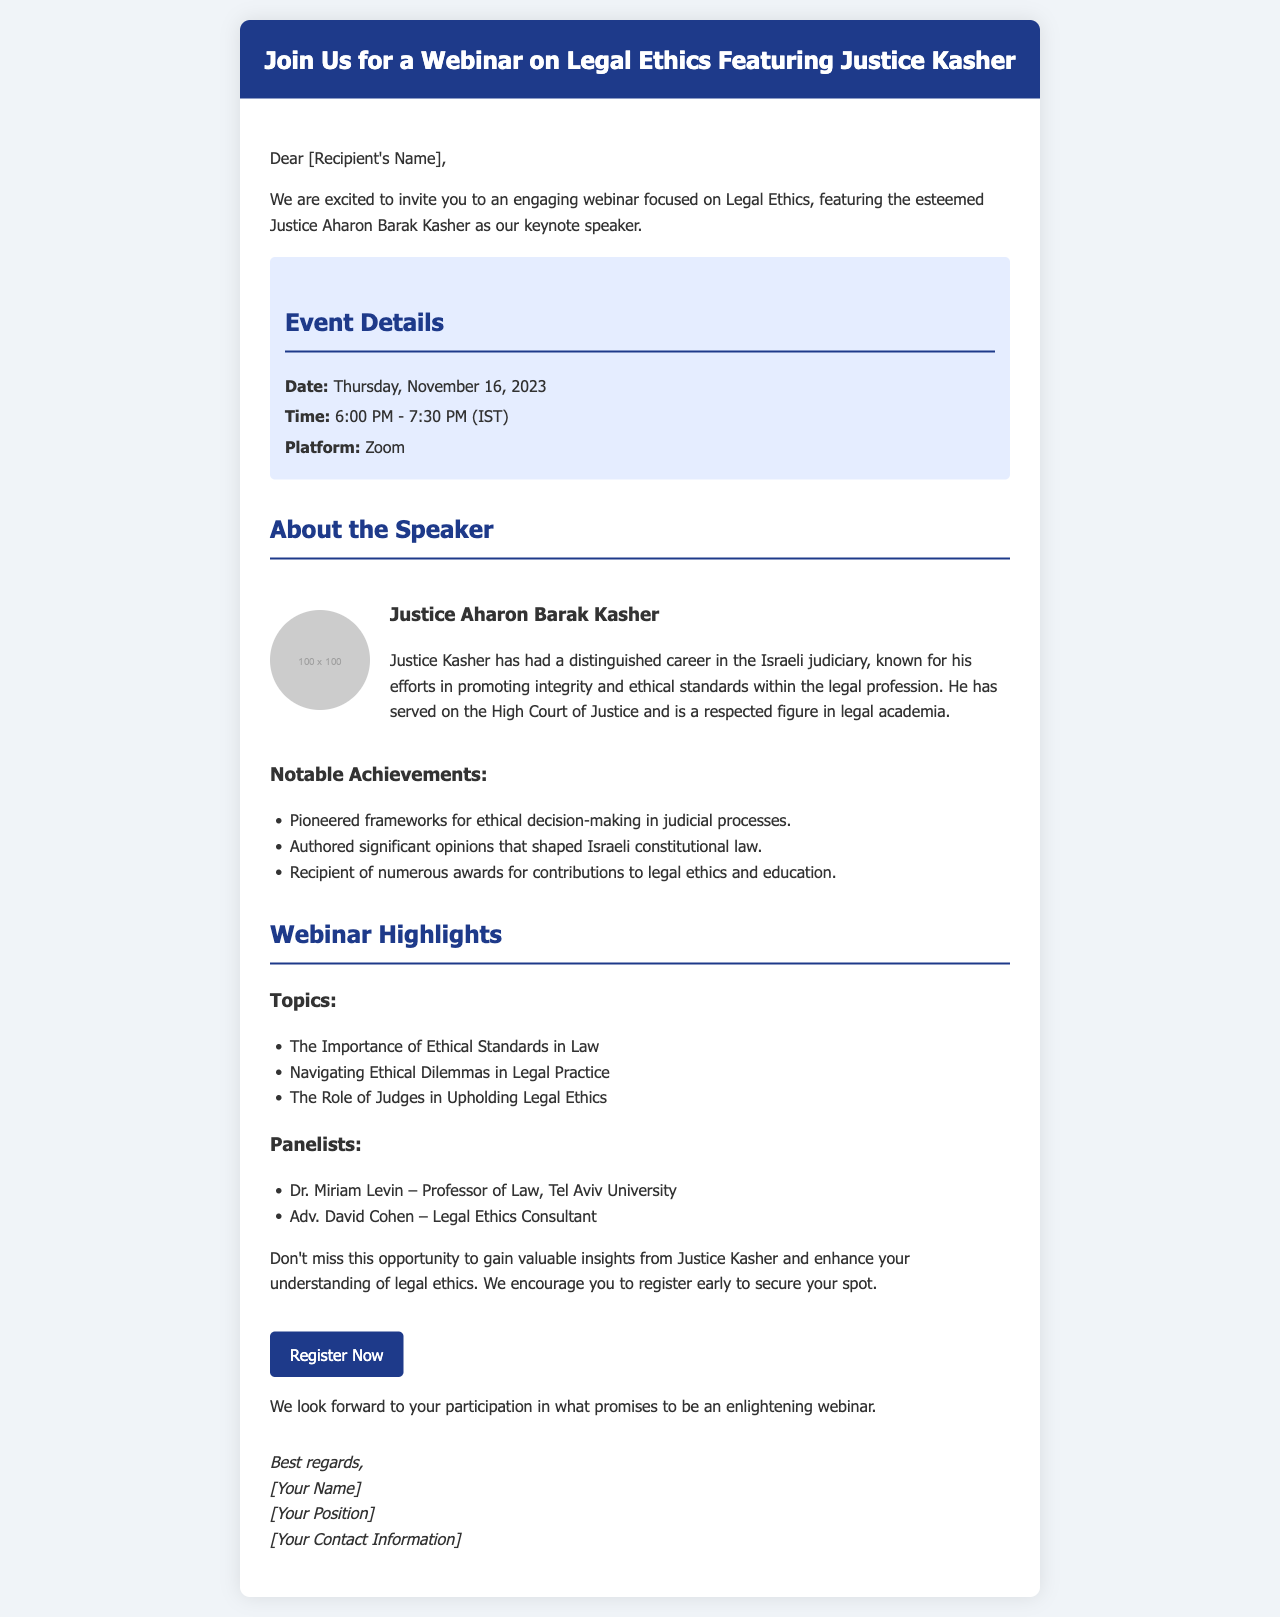What is the date of the webinar? The date of the webinar is explicitly stated in the event details section of the document.
Answer: Thursday, November 16, 2023 What time does the webinar start? The starting time is mentioned in the event details section, specifying the hours for the event.
Answer: 6:00 PM Who is the keynote speaker? The keynote speaker's name is mentioned in the introduction and confirmed later in the document.
Answer: Justice Aharon Barak Kasher What platform will be used for the webinar? The platform for the webinar is indicated in the event details section of the document.
Answer: Zoom What is one of Justice Kasher's notable achievements? The document lists notable achievements of Justice Kasher, one of which can be highlighted.
Answer: Pioneered frameworks for ethical decision-making in judicial processes What topic will be covered regarding judges during the webinar? The topics section specifically mentions the role of judges, which is related to legal ethics.
Answer: The Role of Judges in Upholding Legal Ethics Who is one of the panelists? The document lists panelists participating in the webinar, offering their names as specific examples.
Answer: Dr. Miriam Levin What is the purpose of the webinar invitation? The intention behind sending this invitation is outlined in the introductory paragraph of the document.
Answer: Gain valuable insights from Justice Kasher and enhance understanding of legal ethics 